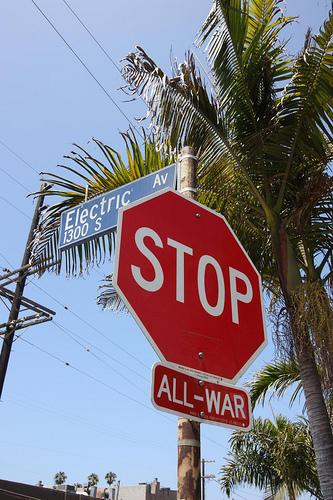What does it say under the stop sign?
Write a very short answer. All-war. What shape is the red sign?
Give a very brief answer. Octagon. Is the person who modified this sign liberal or conservative?
Be succinct. Liberal. What color are the characters on the signs?
Quick response, please. White. Is this a restaurant sign?
Give a very brief answer. No. What does the bottom sign say?
Short answer required. All-war. What is the name on the top street sign?
Quick response, please. Electric. How many signs are there?
Concise answer only. 3. What does it say under Stop?
Be succinct. All-war. How many cables can you see?
Give a very brief answer. 9. Is it summer time?
Give a very brief answer. Yes. Where is this located?
Write a very short answer. Electric ave. What does the second sign say?
Give a very brief answer. All-war. Does this sign appear to be in the United States?
Short answer required. Yes. How does the weather appear in this photo?
Concise answer only. Sunny. 